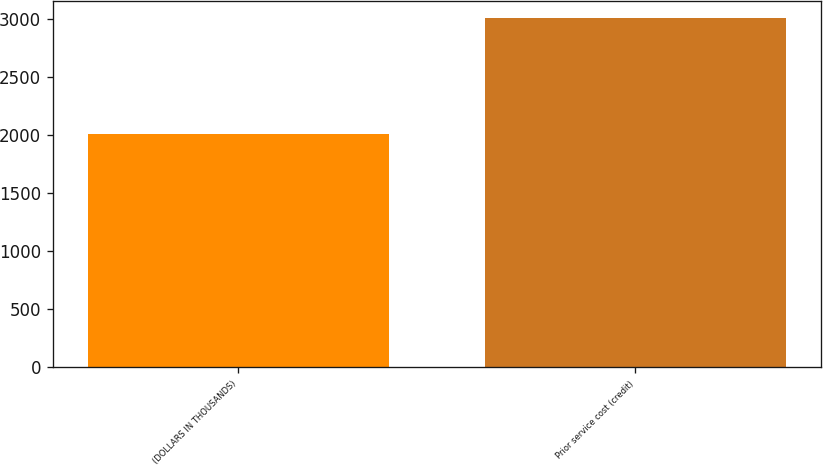Convert chart to OTSL. <chart><loc_0><loc_0><loc_500><loc_500><bar_chart><fcel>(DOLLARS IN THOUSANDS)<fcel>Prior service cost (credit)<nl><fcel>2008<fcel>3007<nl></chart> 